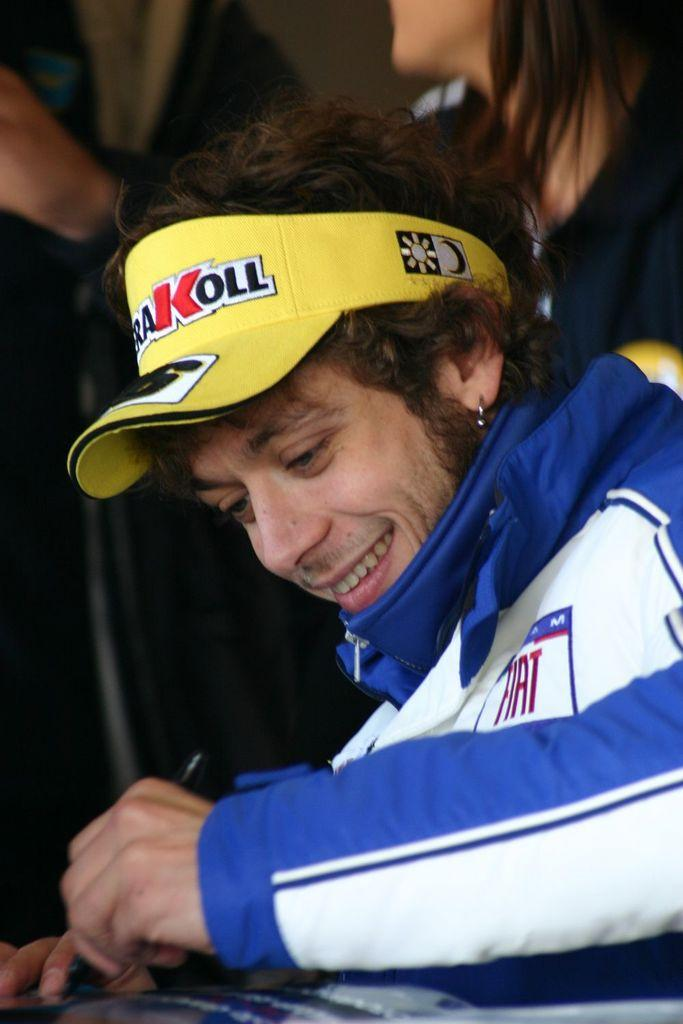What is the person in the image doing? The person is sitting in the image. What expression does the person have? The person is smiling. What object is the person holding? The person is holding a pen. What can be seen on the person's head? The person is wearing a yellow cap. What type of celery is the person eating in the image? There is no celery present in the image; the person is holding a pen. What is the organization of the person's chin in the image? The person's chin is not mentioned in the image, and there is no information about its organization. 